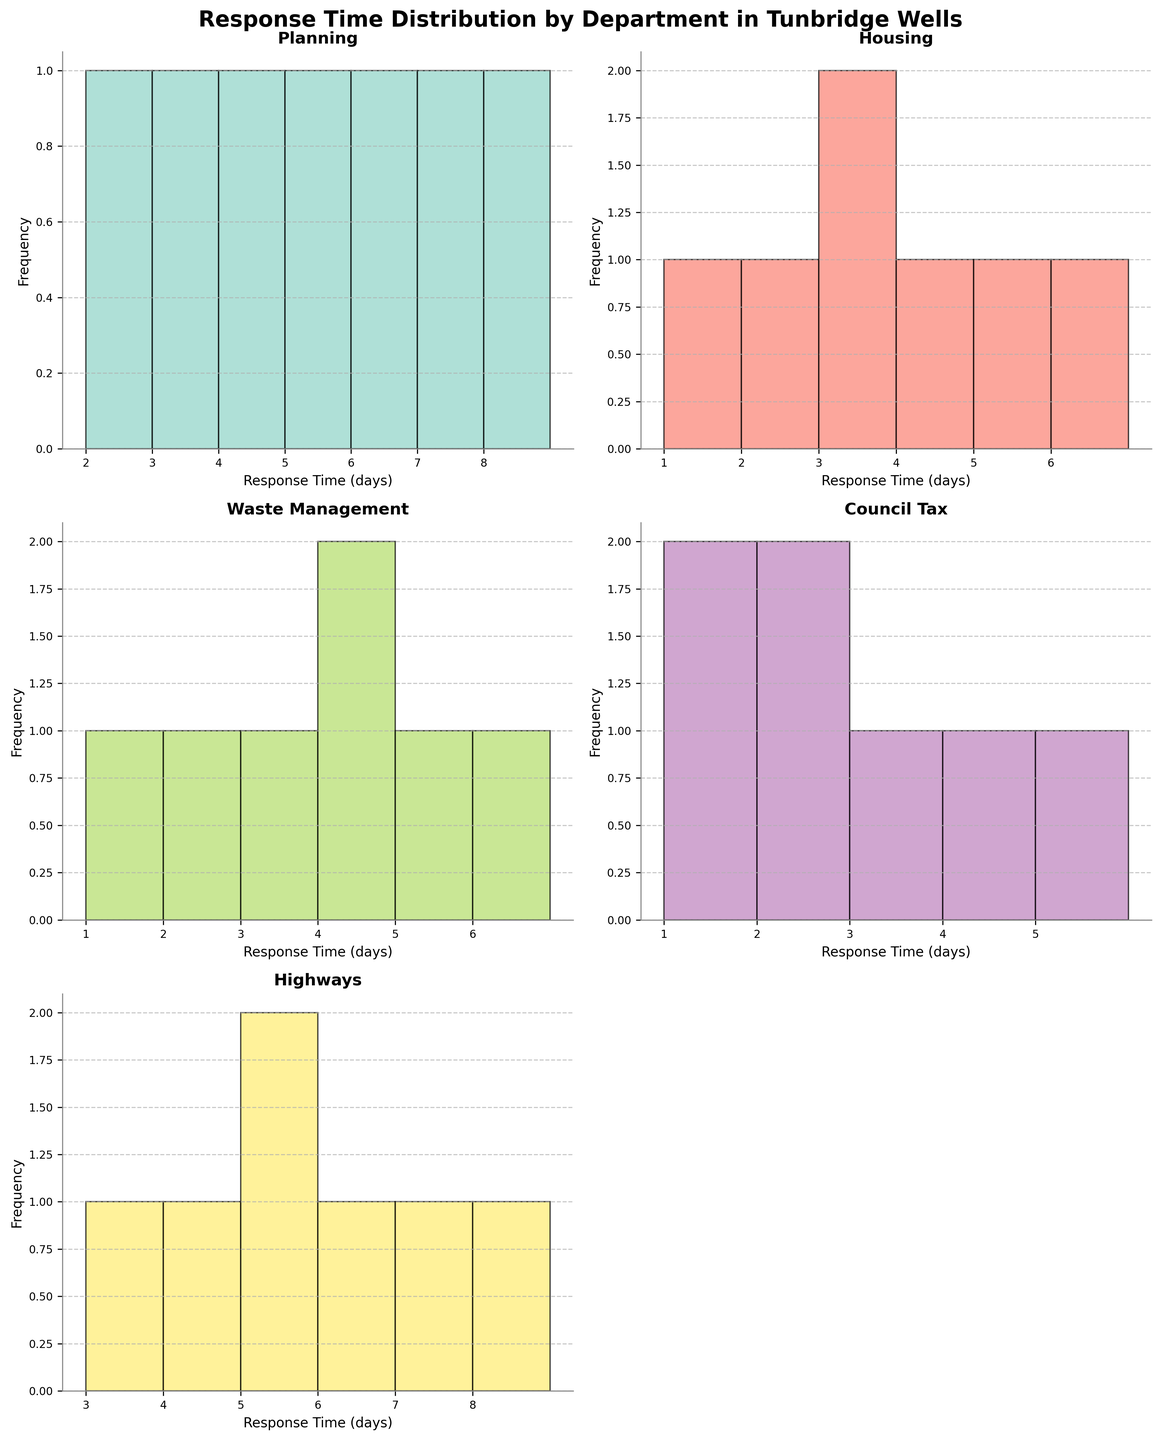What is the title of the figure? The title is written at the top of the figure in large bold font. The main title summarizes the overall content of the figure.
Answer: Response Time Distribution by Department in Tunbridge Wells Which department appears to have the highest frequency of response times at "4 days"? The Planning department shows a visible peak at "4 days" in its histogram.
Answer: Planning How many departments have a peak response time at "2 days"? By examining each individual histogram, it is observed that the Housing and Council Tax departments have prominent bars at "2 days".
Answer: Two departments (Housing and Council Tax) What range of response times is observed in the Highways department? Looking at the histogram for the Highways department, the response times range from the minimum bar at "3 days" to the maximum bar at "8 days".
Answer: 3 to 8 days Which department has the least variability in response times? The Council Tax department's histogram shows response times clustered closely around its range, indicating compact distribution and less variability.
Answer: Council Tax What is the average response time for the Waste Management department? The response times for Waste Management range from 1 to 6. To find the average: (1 + 2 + 3 + 4 + 4 + 5 + 6) / 7 = 25 / 7 ≈ 3.57.
Answer: Approximately 3.57 days Is there any department with a response time consistently lower than 3 days? By analyzing the histograms, the Housing department has several bars indicating response times less than 3 days. This consistency in lower times isn't observed in other departments.
Answer: Housing Which two departments share the exact same range of response times? Both Planning and Highways departments have response times that range from 3 to 8 days, as indicated by their histograms.
Answer: Planning and Highways Identify the department with the most balanced histogram. The Waste Management department's histogram shows a relatively symmetrical distribution around the central response times, suggesting a balanced spread.
Answer: Waste Management What is the most common response time range across all departments? Examining all histograms, the response times between 3 and 5 days are the most common, as several departments show high frequencies in this range.
Answer: 3 to 5 days 